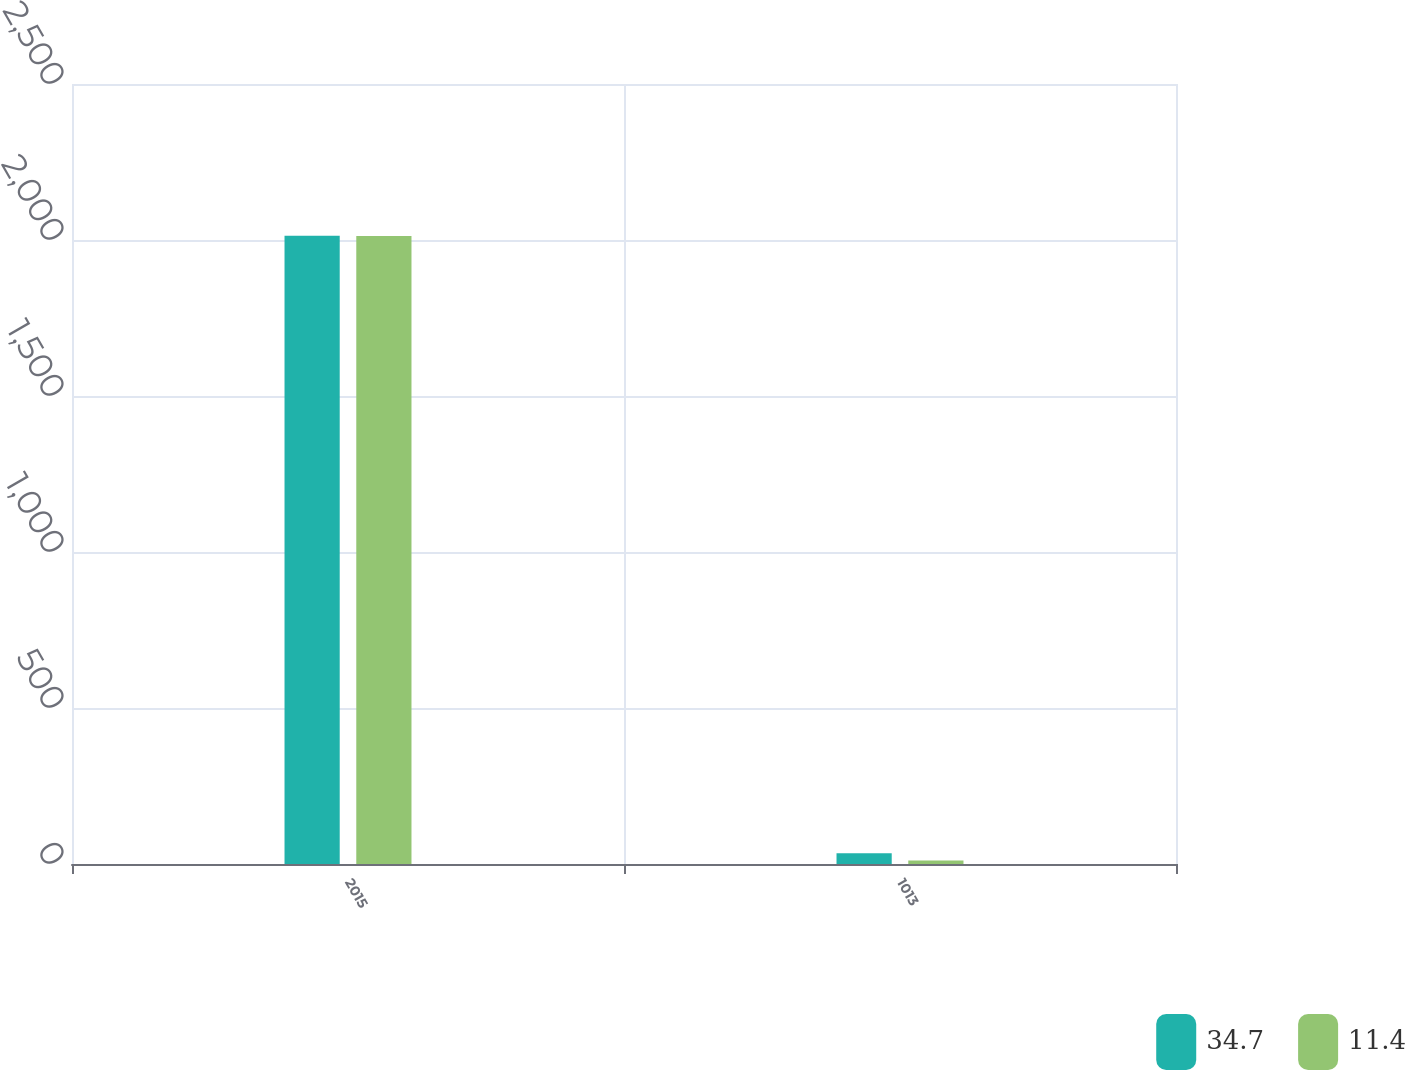<chart> <loc_0><loc_0><loc_500><loc_500><stacked_bar_chart><ecel><fcel>2015<fcel>1013<nl><fcel>34.7<fcel>2014<fcel>34.7<nl><fcel>11.4<fcel>2013<fcel>11.4<nl></chart> 